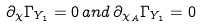Convert formula to latex. <formula><loc_0><loc_0><loc_500><loc_500>\partial _ { \chi } \Gamma _ { Y _ { 1 } } = 0 \, a n d \, \partial _ { \chi _ { A } } \Gamma _ { Y _ { 1 } } = 0</formula> 